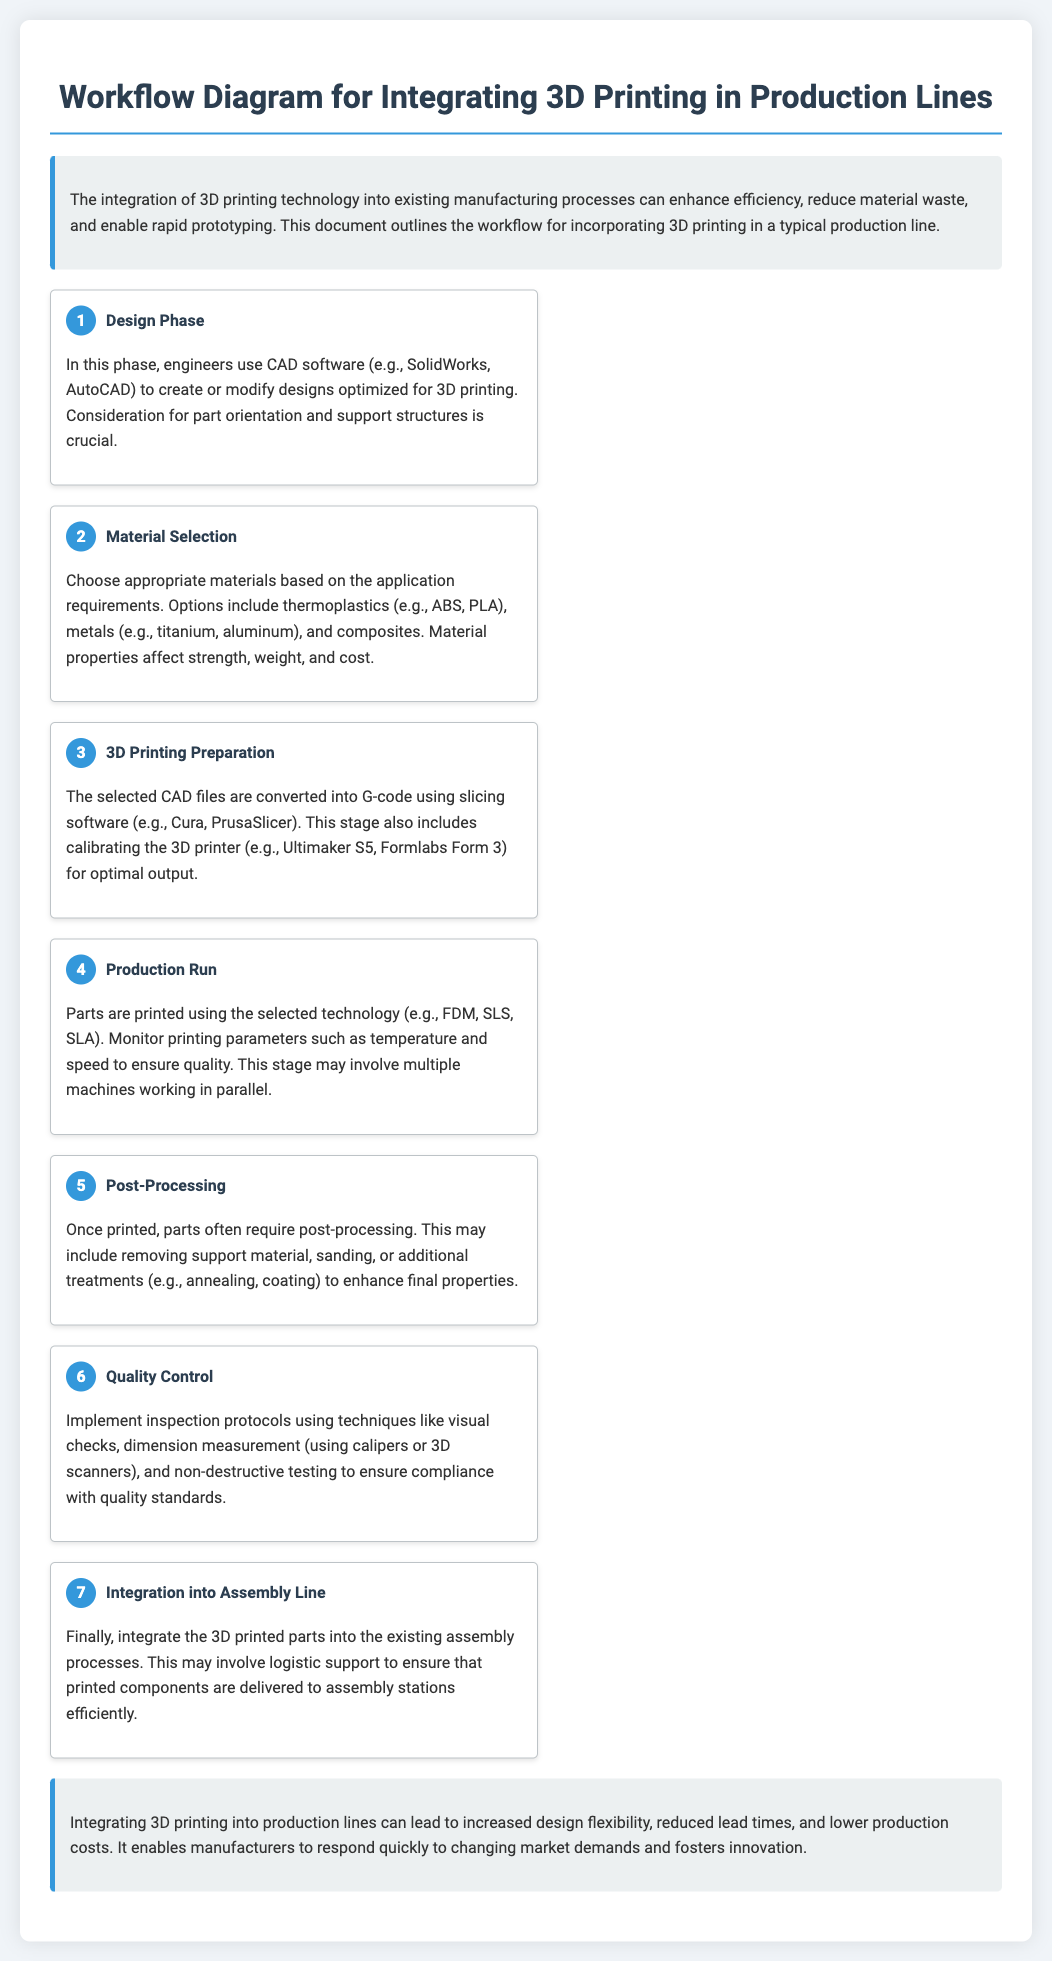what is the first step in the workflow? The first step in the workflow is listed as "Design Phase," which involves creating or modifying designs optimized for 3D printing.
Answer: Design Phase what software is mentioned for the Design Phase? The document specifies CAD software such as SolidWorks and AutoCAD for use in the Design Phase.
Answer: SolidWorks, AutoCAD which materials are suggested for 3D printing? The document lists thermoplastics, metals, and composites as suitable materials based on application requirements.
Answer: Thermoplastics, metals, composites how many steps are there in the workflow? The workflow outlines a total of seven steps in the production integration process of 3D printing.
Answer: Seven what is the primary goal of Quality Control? The main goal of Quality Control is to ensure compliance with quality standards through inspection protocols.
Answer: Compliance with quality standards what process follows 3D Printing Preparation? The document indicates that the "Production Run" follows the "3D Printing Preparation" step in the workflow.
Answer: Production Run what is one benefit of integrating 3D printing into production lines? The document mentions that integrating 3D printing can lead to increased design flexibility as one of its benefits.
Answer: Increased design flexibility what is involved in the Post-Processing step? Post-Processing may include removing support material, sanding, or additional treatments to enhance final properties.
Answer: Removing support material, sanding, additional treatments how does the document recommend ensuring that printed components reach assembly stations efficiently? The document suggests that logistic support is necessary to ensure the efficient delivery of printed components to assembly stations.
Answer: Logistic support 